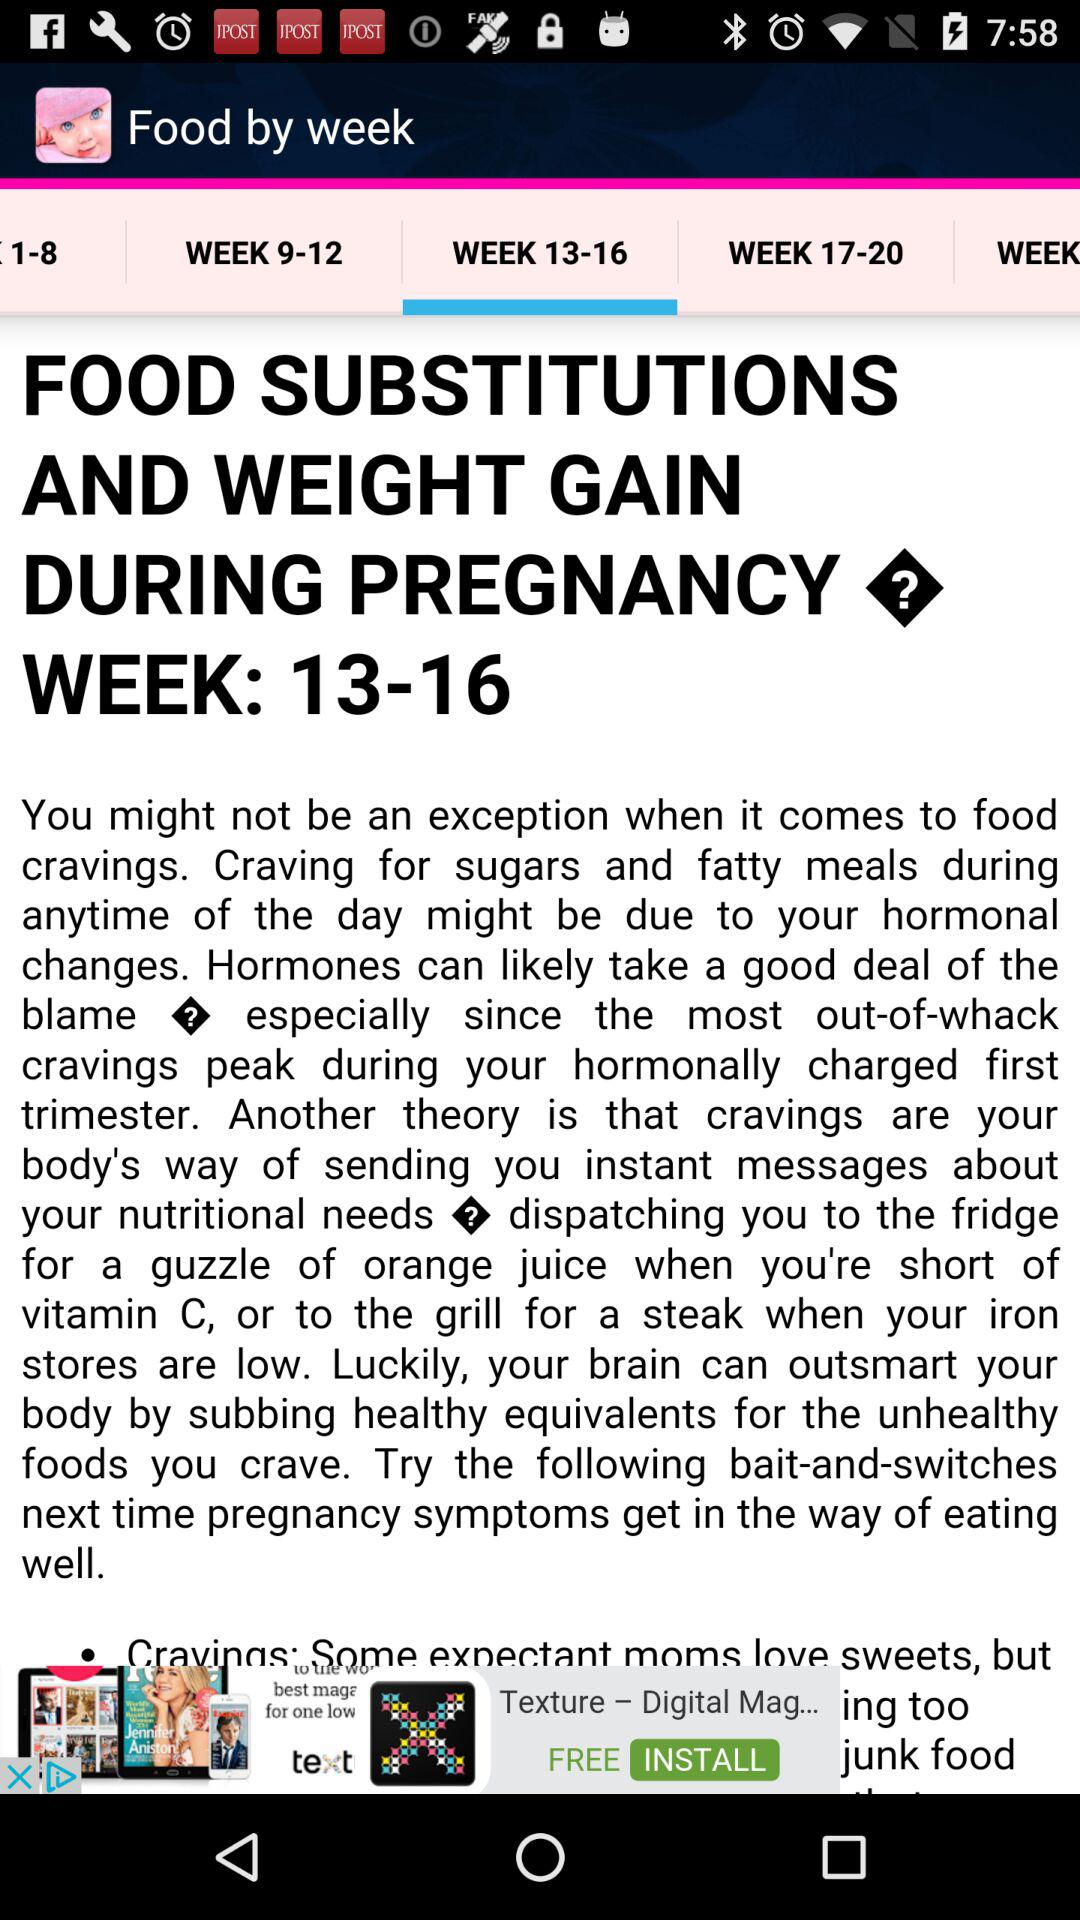What foods are needed for weeks 17 through 20?
When the provided information is insufficient, respond with <no answer>. <no answer> 